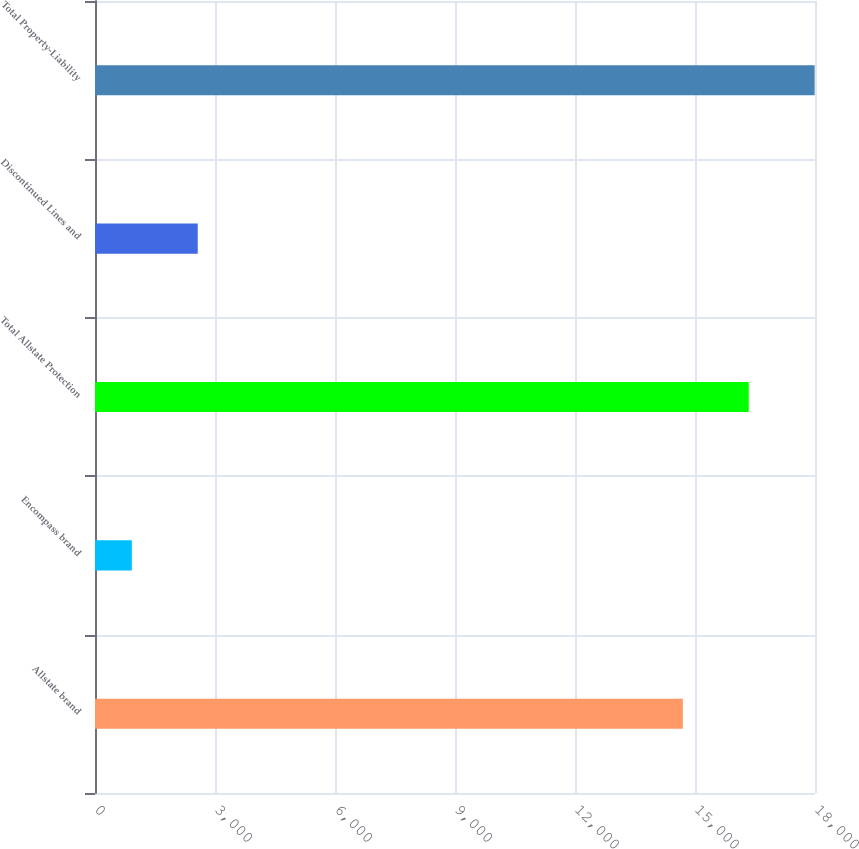<chart> <loc_0><loc_0><loc_500><loc_500><bar_chart><fcel>Allstate brand<fcel>Encompass brand<fcel>Total Allstate Protection<fcel>Discontinued Lines and<fcel>Total Property-Liability<nl><fcel>14696<fcel>921<fcel>16343.5<fcel>2568.5<fcel>17991<nl></chart> 